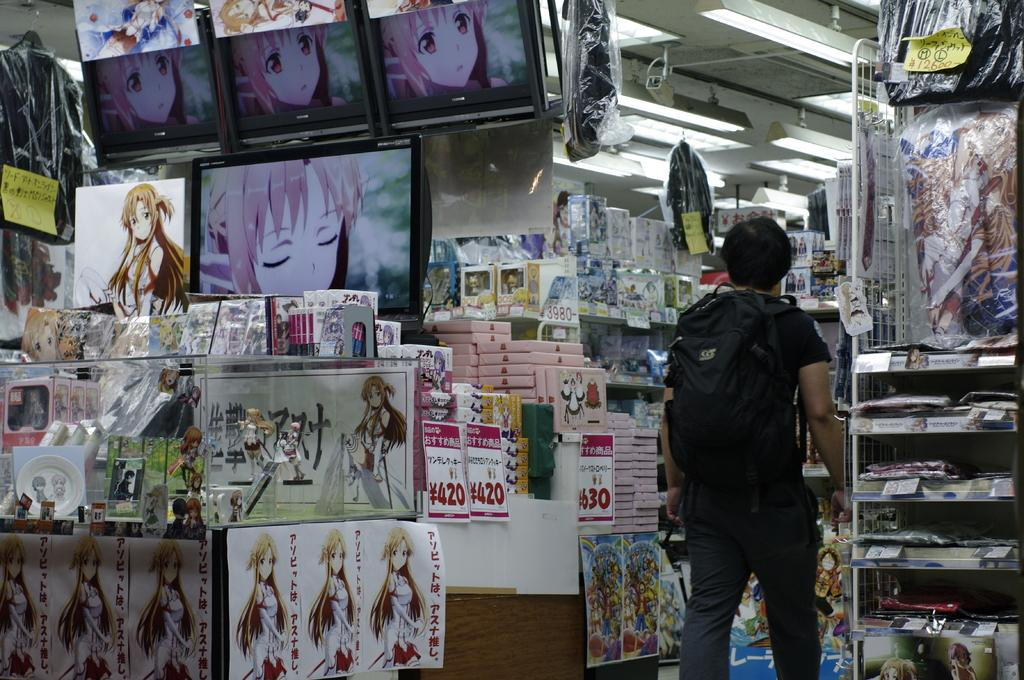What type of objects can be seen on the walls in the image? There are posters in the image. What type of objects can be seen on the floor or other surfaces in the image? There are screens, boxes, frames, and racks in the image. What type of lighting is present in the image? There are lights in the image. What part of the room is visible in the image? The ceiling is visible in the image. Is there a person present in the image? Yes, there is a person in the image. What is the person wearing that might be used for carrying items? The person is wearing a bag. Is there any rain visible in the image? No, there is no rain visible in the image. Can you see any stems in the image? No, there are no stems present in the image. 